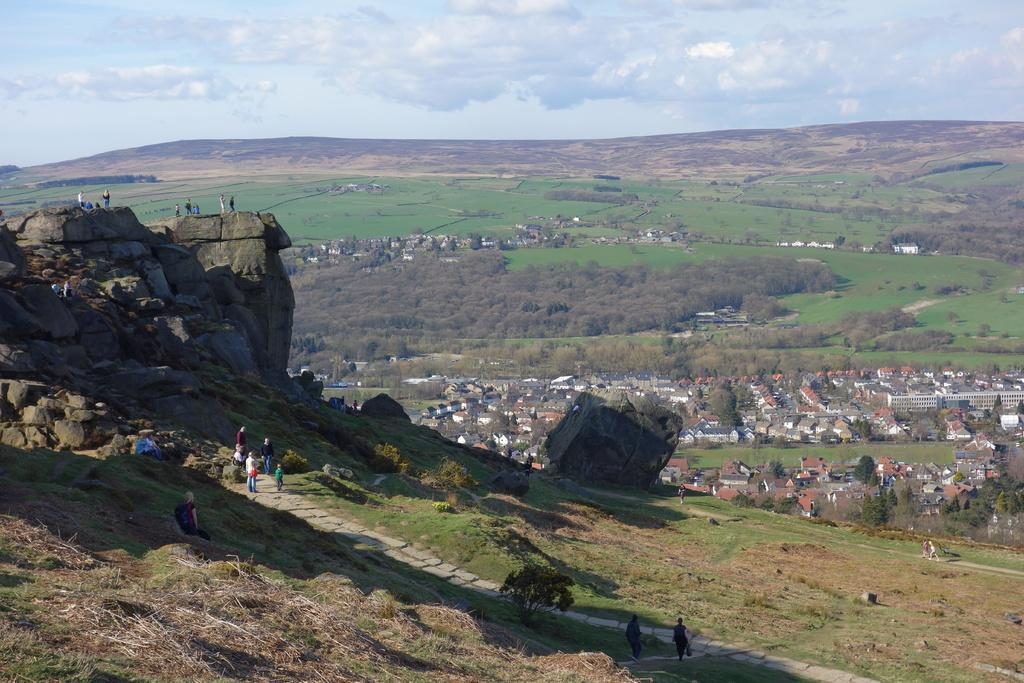What type of natural elements can be seen in the image? There are rocks and grass in the image. Can you describe the people in the image? There is a group of people standing in the image. What other objects or structures are present in the image? There are trees and houses in the image. How would you describe the weather in the image? The sky is cloudy in the image. What type of drawer is being used by the people in the image? There is no drawer present in the image; it features rocks, grass, a group of people, trees, houses, and a cloudy sky. What subject are the people in the image teaching each other? There is no indication in the image that the people are teaching each other, as their actions are not described. 